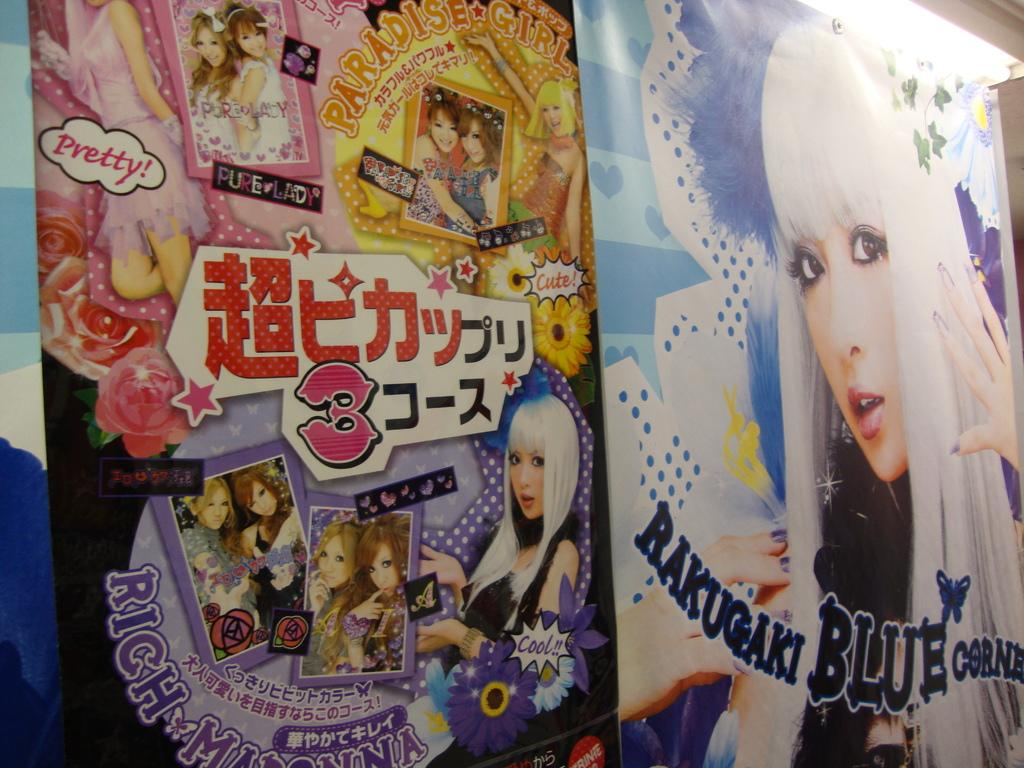What is the main object in the image? There is a poster in the image. What type of images are on the poster? The poster contains images of women. Is there any text on the poster? Yes, there is text on the poster. How many hands are visible on the poster? There is no mention of hands in the image, as the poster contains images of women and text. 